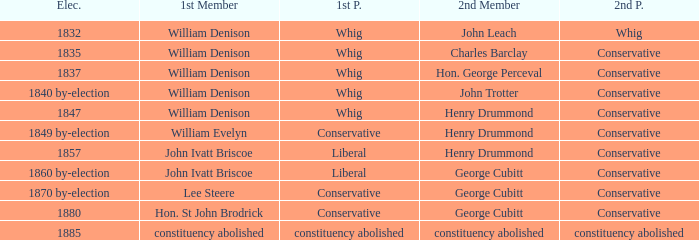Which party's 1st member is William Denison in the election of 1832? Whig. 